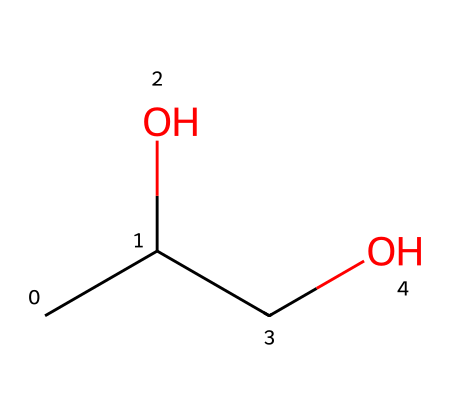What is the molecular formula for propylene glycol? The molecular formula is derived by counting the number of each type of atom present in the SMILES representation. For "CC(O)CO," there are three carbon (C) atoms, eight hydrogen (H) atoms, and two oxygen (O) atoms, leading to the formula C3H8O2.
Answer: C3H8O2 How many carbon atoms are in propylene glycol? By examining the SMILES representation "CC(O)CO," we count the 'C's in the structure. There are three carbon atoms in total.
Answer: 3 What functional group is present in propylene glycol? In the SMILES "CC(O)CO," the '(O)' indicates a hydroxyl group (–OH), which is characteristic of alcohols. This functional group is responsible for its properties as a moisture-retaining agent.
Answer: hydroxyl What type of compound is propylene glycol classified as? Propylene glycol possesses a hydroxyl functional group and is primarily categorized as an alcohol, specifically a diol due to the presence of two hydroxyl groups in the structure.
Answer: alcohol What is propylene glycol’s role in food products? Propylene glycol functions primarily as a moisture-retaining agent, helping to maintain moisture in packaged baked goods, thus improving shelf life and texture.
Answer: moisture-retaining agent Does propylene glycol contain any double bonds? Analyzing the SMILES "CC(O)CO," there are no occurrences of double bonds (indicated by '=' in chemical structures), as all connections between carbon, hydrogen, and oxygen are single bonds in this compound.
Answer: no 